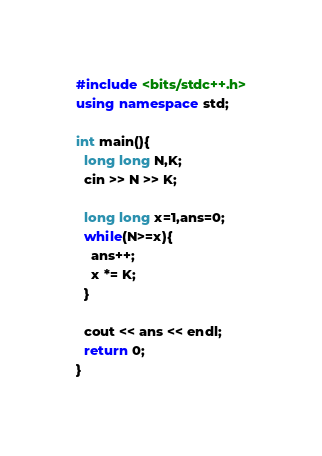<code> <loc_0><loc_0><loc_500><loc_500><_C++_>#include <bits/stdc++.h>
using namespace std;

int main(){
  long long N,K;
  cin >> N >> K;
  
  long long x=1,ans=0;
  while(N>=x){
    ans++;
    x *= K;
  }
  
  cout << ans << endl;
  return 0;
}
</code> 